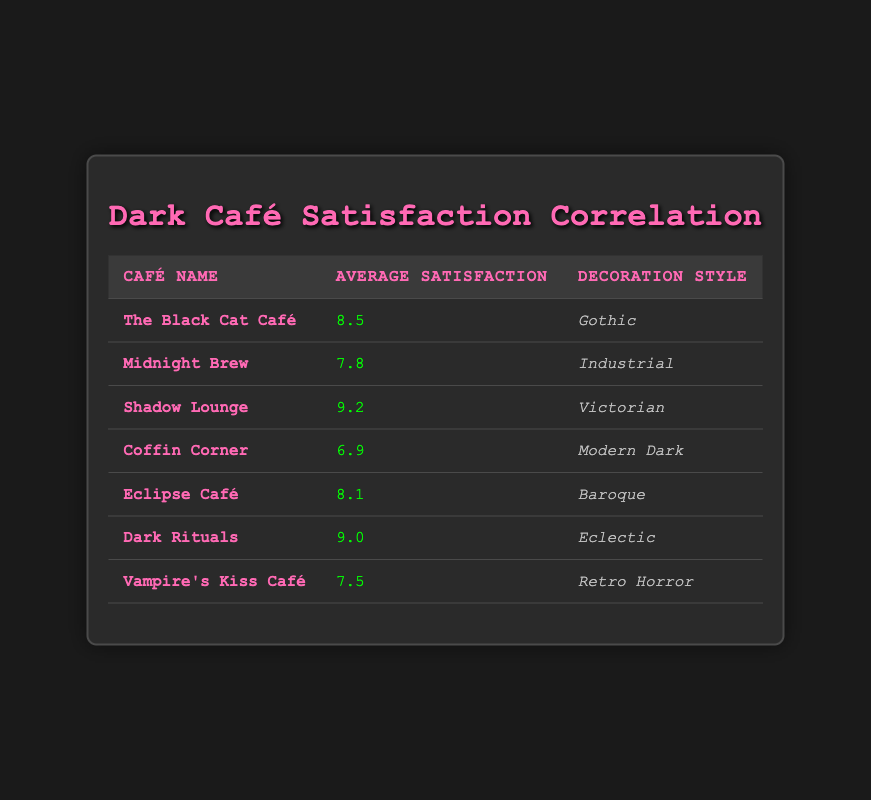What is the average customer satisfaction score for cafes with a Gothic decoration style? The table shows that "The Black Cat Café" has an average customer satisfaction score of 8.5. Since it is the only café with a Gothic style, the average is simply its score.
Answer: 8.5 Which café has the highest customer satisfaction score? The highest score in the table is 9.2, which belongs to "Shadow Lounge."
Answer: Shadow Lounge Are there any cafes with a Modern Dark decoration style? Yes, "Coffin Corner" has a Modern Dark decoration style.
Answer: Yes What is the average customer satisfaction score for all cafes listed? To find the average score, sum the scores: 8.5 + 7.8 + 9.2 + 6.9 + 8.1 + 9.0 + 7.5 = 57.0. There are 7 cafes, so the average is 57.0 / 7 = 8.14.
Answer: 8.14 Is the decoration style of "Dark Rituals" associated with a higher customer satisfaction score than "Vampire's Kiss Café"? "Dark Rituals" has a score of 9.0, while "Vampire's Kiss Café" has a score of 7.5. Since 9.0 is greater than 7.5, Dark Rituals is indeed associated with a higher score.
Answer: Yes What is the difference in customer satisfaction scores between the café with the highest score and the one with the lowest? "Shadow Lounge" has the highest score of 9.2, and "Coffin Corner" has the lowest score of 6.9. The difference is 9.2 - 6.9 = 2.3.
Answer: 2.3 How many cafes have a customer satisfaction score greater than 8.0? The cafes with scores of 9.2, 9.0, and 8.5 are above 8.0. Counting these gives us three cafes.
Answer: 3 Does the table indicate that the Industrial decoration style corresponds to a higher satisfaction score than the Retro Horror style? "Midnight Brew," with an Industrial style, has a score of 7.8, while "Vampire's Kiss Café," with Retro Horror style, has a score of 7.5. Since 7.8 is greater than 7.5, we can conclude that it does.
Answer: Yes Which decoration style correlates with the second-highest average customer satisfaction score? "Dark Rituals" has an average score of 9.0, which is second highest after "Shadow Lounge" at 9.2. The decoration style for "Dark Rituals" is Eclectic.
Answer: Eclectic 